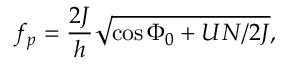<formula> <loc_0><loc_0><loc_500><loc_500>f _ { p } = \frac { 2 J } { h } \sqrt { \cos \Phi _ { 0 } + U N / 2 J } ,</formula> 